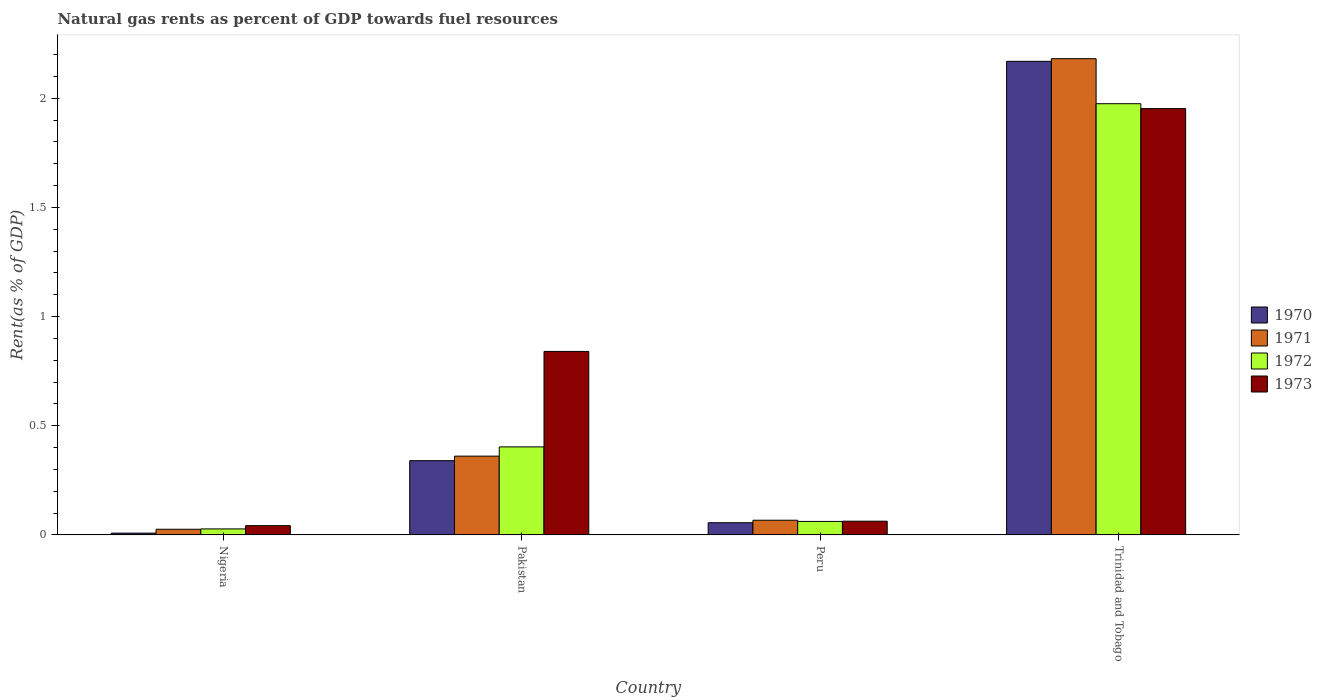Are the number of bars per tick equal to the number of legend labels?
Offer a very short reply. Yes. How many bars are there on the 4th tick from the left?
Provide a succinct answer. 4. How many bars are there on the 3rd tick from the right?
Give a very brief answer. 4. What is the matural gas rent in 1970 in Pakistan?
Keep it short and to the point. 0.34. Across all countries, what is the maximum matural gas rent in 1971?
Your response must be concise. 2.18. Across all countries, what is the minimum matural gas rent in 1972?
Your answer should be compact. 0.03. In which country was the matural gas rent in 1973 maximum?
Offer a very short reply. Trinidad and Tobago. In which country was the matural gas rent in 1970 minimum?
Provide a short and direct response. Nigeria. What is the total matural gas rent in 1971 in the graph?
Your answer should be compact. 2.64. What is the difference between the matural gas rent in 1972 in Nigeria and that in Trinidad and Tobago?
Provide a short and direct response. -1.95. What is the difference between the matural gas rent in 1970 in Peru and the matural gas rent in 1971 in Nigeria?
Your response must be concise. 0.03. What is the average matural gas rent in 1970 per country?
Offer a very short reply. 0.64. What is the difference between the matural gas rent of/in 1971 and matural gas rent of/in 1973 in Trinidad and Tobago?
Ensure brevity in your answer.  0.23. In how many countries, is the matural gas rent in 1971 greater than 1.6 %?
Ensure brevity in your answer.  1. What is the ratio of the matural gas rent in 1970 in Pakistan to that in Peru?
Provide a succinct answer. 6.1. Is the matural gas rent in 1970 in Nigeria less than that in Pakistan?
Your response must be concise. Yes. What is the difference between the highest and the second highest matural gas rent in 1970?
Provide a succinct answer. -1.83. What is the difference between the highest and the lowest matural gas rent in 1971?
Offer a terse response. 2.16. Is it the case that in every country, the sum of the matural gas rent in 1973 and matural gas rent in 1971 is greater than the sum of matural gas rent in 1970 and matural gas rent in 1972?
Make the answer very short. No. What does the 1st bar from the left in Pakistan represents?
Make the answer very short. 1970. What does the 4th bar from the right in Peru represents?
Provide a succinct answer. 1970. Are all the bars in the graph horizontal?
Ensure brevity in your answer.  No. Are the values on the major ticks of Y-axis written in scientific E-notation?
Offer a terse response. No. Does the graph contain any zero values?
Your answer should be compact. No. Does the graph contain grids?
Offer a very short reply. No. Where does the legend appear in the graph?
Give a very brief answer. Center right. How are the legend labels stacked?
Keep it short and to the point. Vertical. What is the title of the graph?
Make the answer very short. Natural gas rents as percent of GDP towards fuel resources. What is the label or title of the Y-axis?
Offer a terse response. Rent(as % of GDP). What is the Rent(as % of GDP) in 1970 in Nigeria?
Your answer should be compact. 0.01. What is the Rent(as % of GDP) in 1971 in Nigeria?
Make the answer very short. 0.03. What is the Rent(as % of GDP) in 1972 in Nigeria?
Keep it short and to the point. 0.03. What is the Rent(as % of GDP) in 1973 in Nigeria?
Your answer should be very brief. 0.04. What is the Rent(as % of GDP) in 1970 in Pakistan?
Ensure brevity in your answer.  0.34. What is the Rent(as % of GDP) in 1971 in Pakistan?
Your response must be concise. 0.36. What is the Rent(as % of GDP) in 1972 in Pakistan?
Offer a very short reply. 0.4. What is the Rent(as % of GDP) in 1973 in Pakistan?
Keep it short and to the point. 0.84. What is the Rent(as % of GDP) of 1970 in Peru?
Make the answer very short. 0.06. What is the Rent(as % of GDP) of 1971 in Peru?
Your response must be concise. 0.07. What is the Rent(as % of GDP) in 1972 in Peru?
Your answer should be compact. 0.06. What is the Rent(as % of GDP) in 1973 in Peru?
Provide a succinct answer. 0.06. What is the Rent(as % of GDP) of 1970 in Trinidad and Tobago?
Ensure brevity in your answer.  2.17. What is the Rent(as % of GDP) of 1971 in Trinidad and Tobago?
Offer a terse response. 2.18. What is the Rent(as % of GDP) of 1972 in Trinidad and Tobago?
Your answer should be compact. 1.98. What is the Rent(as % of GDP) in 1973 in Trinidad and Tobago?
Offer a terse response. 1.95. Across all countries, what is the maximum Rent(as % of GDP) of 1970?
Make the answer very short. 2.17. Across all countries, what is the maximum Rent(as % of GDP) in 1971?
Ensure brevity in your answer.  2.18. Across all countries, what is the maximum Rent(as % of GDP) in 1972?
Give a very brief answer. 1.98. Across all countries, what is the maximum Rent(as % of GDP) in 1973?
Your response must be concise. 1.95. Across all countries, what is the minimum Rent(as % of GDP) of 1970?
Your response must be concise. 0.01. Across all countries, what is the minimum Rent(as % of GDP) in 1971?
Give a very brief answer. 0.03. Across all countries, what is the minimum Rent(as % of GDP) of 1972?
Provide a short and direct response. 0.03. Across all countries, what is the minimum Rent(as % of GDP) of 1973?
Give a very brief answer. 0.04. What is the total Rent(as % of GDP) of 1970 in the graph?
Ensure brevity in your answer.  2.57. What is the total Rent(as % of GDP) of 1971 in the graph?
Offer a terse response. 2.64. What is the total Rent(as % of GDP) in 1972 in the graph?
Your response must be concise. 2.47. What is the total Rent(as % of GDP) of 1973 in the graph?
Your answer should be compact. 2.9. What is the difference between the Rent(as % of GDP) in 1970 in Nigeria and that in Pakistan?
Offer a terse response. -0.33. What is the difference between the Rent(as % of GDP) in 1971 in Nigeria and that in Pakistan?
Provide a succinct answer. -0.34. What is the difference between the Rent(as % of GDP) of 1972 in Nigeria and that in Pakistan?
Keep it short and to the point. -0.38. What is the difference between the Rent(as % of GDP) in 1973 in Nigeria and that in Pakistan?
Your answer should be very brief. -0.8. What is the difference between the Rent(as % of GDP) in 1970 in Nigeria and that in Peru?
Keep it short and to the point. -0.05. What is the difference between the Rent(as % of GDP) of 1971 in Nigeria and that in Peru?
Provide a short and direct response. -0.04. What is the difference between the Rent(as % of GDP) of 1972 in Nigeria and that in Peru?
Your answer should be very brief. -0.03. What is the difference between the Rent(as % of GDP) of 1973 in Nigeria and that in Peru?
Offer a terse response. -0.02. What is the difference between the Rent(as % of GDP) of 1970 in Nigeria and that in Trinidad and Tobago?
Ensure brevity in your answer.  -2.16. What is the difference between the Rent(as % of GDP) of 1971 in Nigeria and that in Trinidad and Tobago?
Give a very brief answer. -2.16. What is the difference between the Rent(as % of GDP) in 1972 in Nigeria and that in Trinidad and Tobago?
Ensure brevity in your answer.  -1.95. What is the difference between the Rent(as % of GDP) in 1973 in Nigeria and that in Trinidad and Tobago?
Make the answer very short. -1.91. What is the difference between the Rent(as % of GDP) of 1970 in Pakistan and that in Peru?
Offer a very short reply. 0.28. What is the difference between the Rent(as % of GDP) in 1971 in Pakistan and that in Peru?
Give a very brief answer. 0.29. What is the difference between the Rent(as % of GDP) in 1972 in Pakistan and that in Peru?
Your response must be concise. 0.34. What is the difference between the Rent(as % of GDP) of 1973 in Pakistan and that in Peru?
Keep it short and to the point. 0.78. What is the difference between the Rent(as % of GDP) in 1970 in Pakistan and that in Trinidad and Tobago?
Provide a succinct answer. -1.83. What is the difference between the Rent(as % of GDP) of 1971 in Pakistan and that in Trinidad and Tobago?
Provide a succinct answer. -1.82. What is the difference between the Rent(as % of GDP) in 1972 in Pakistan and that in Trinidad and Tobago?
Keep it short and to the point. -1.57. What is the difference between the Rent(as % of GDP) in 1973 in Pakistan and that in Trinidad and Tobago?
Keep it short and to the point. -1.11. What is the difference between the Rent(as % of GDP) in 1970 in Peru and that in Trinidad and Tobago?
Provide a short and direct response. -2.11. What is the difference between the Rent(as % of GDP) of 1971 in Peru and that in Trinidad and Tobago?
Provide a short and direct response. -2.11. What is the difference between the Rent(as % of GDP) in 1972 in Peru and that in Trinidad and Tobago?
Your answer should be very brief. -1.91. What is the difference between the Rent(as % of GDP) in 1973 in Peru and that in Trinidad and Tobago?
Provide a succinct answer. -1.89. What is the difference between the Rent(as % of GDP) of 1970 in Nigeria and the Rent(as % of GDP) of 1971 in Pakistan?
Keep it short and to the point. -0.35. What is the difference between the Rent(as % of GDP) in 1970 in Nigeria and the Rent(as % of GDP) in 1972 in Pakistan?
Keep it short and to the point. -0.4. What is the difference between the Rent(as % of GDP) of 1970 in Nigeria and the Rent(as % of GDP) of 1973 in Pakistan?
Provide a succinct answer. -0.83. What is the difference between the Rent(as % of GDP) of 1971 in Nigeria and the Rent(as % of GDP) of 1972 in Pakistan?
Offer a terse response. -0.38. What is the difference between the Rent(as % of GDP) of 1971 in Nigeria and the Rent(as % of GDP) of 1973 in Pakistan?
Your response must be concise. -0.81. What is the difference between the Rent(as % of GDP) in 1972 in Nigeria and the Rent(as % of GDP) in 1973 in Pakistan?
Provide a succinct answer. -0.81. What is the difference between the Rent(as % of GDP) in 1970 in Nigeria and the Rent(as % of GDP) in 1971 in Peru?
Provide a short and direct response. -0.06. What is the difference between the Rent(as % of GDP) of 1970 in Nigeria and the Rent(as % of GDP) of 1972 in Peru?
Your response must be concise. -0.05. What is the difference between the Rent(as % of GDP) in 1970 in Nigeria and the Rent(as % of GDP) in 1973 in Peru?
Provide a short and direct response. -0.05. What is the difference between the Rent(as % of GDP) of 1971 in Nigeria and the Rent(as % of GDP) of 1972 in Peru?
Ensure brevity in your answer.  -0.04. What is the difference between the Rent(as % of GDP) of 1971 in Nigeria and the Rent(as % of GDP) of 1973 in Peru?
Give a very brief answer. -0.04. What is the difference between the Rent(as % of GDP) in 1972 in Nigeria and the Rent(as % of GDP) in 1973 in Peru?
Your answer should be very brief. -0.04. What is the difference between the Rent(as % of GDP) of 1970 in Nigeria and the Rent(as % of GDP) of 1971 in Trinidad and Tobago?
Make the answer very short. -2.17. What is the difference between the Rent(as % of GDP) of 1970 in Nigeria and the Rent(as % of GDP) of 1972 in Trinidad and Tobago?
Your response must be concise. -1.97. What is the difference between the Rent(as % of GDP) of 1970 in Nigeria and the Rent(as % of GDP) of 1973 in Trinidad and Tobago?
Ensure brevity in your answer.  -1.94. What is the difference between the Rent(as % of GDP) in 1971 in Nigeria and the Rent(as % of GDP) in 1972 in Trinidad and Tobago?
Your response must be concise. -1.95. What is the difference between the Rent(as % of GDP) in 1971 in Nigeria and the Rent(as % of GDP) in 1973 in Trinidad and Tobago?
Your answer should be compact. -1.93. What is the difference between the Rent(as % of GDP) in 1972 in Nigeria and the Rent(as % of GDP) in 1973 in Trinidad and Tobago?
Make the answer very short. -1.93. What is the difference between the Rent(as % of GDP) of 1970 in Pakistan and the Rent(as % of GDP) of 1971 in Peru?
Provide a succinct answer. 0.27. What is the difference between the Rent(as % of GDP) in 1970 in Pakistan and the Rent(as % of GDP) in 1972 in Peru?
Your answer should be very brief. 0.28. What is the difference between the Rent(as % of GDP) in 1970 in Pakistan and the Rent(as % of GDP) in 1973 in Peru?
Your answer should be compact. 0.28. What is the difference between the Rent(as % of GDP) of 1971 in Pakistan and the Rent(as % of GDP) of 1972 in Peru?
Make the answer very short. 0.3. What is the difference between the Rent(as % of GDP) of 1971 in Pakistan and the Rent(as % of GDP) of 1973 in Peru?
Give a very brief answer. 0.3. What is the difference between the Rent(as % of GDP) of 1972 in Pakistan and the Rent(as % of GDP) of 1973 in Peru?
Make the answer very short. 0.34. What is the difference between the Rent(as % of GDP) of 1970 in Pakistan and the Rent(as % of GDP) of 1971 in Trinidad and Tobago?
Ensure brevity in your answer.  -1.84. What is the difference between the Rent(as % of GDP) in 1970 in Pakistan and the Rent(as % of GDP) in 1972 in Trinidad and Tobago?
Provide a succinct answer. -1.64. What is the difference between the Rent(as % of GDP) in 1970 in Pakistan and the Rent(as % of GDP) in 1973 in Trinidad and Tobago?
Your response must be concise. -1.61. What is the difference between the Rent(as % of GDP) of 1971 in Pakistan and the Rent(as % of GDP) of 1972 in Trinidad and Tobago?
Your answer should be compact. -1.61. What is the difference between the Rent(as % of GDP) in 1971 in Pakistan and the Rent(as % of GDP) in 1973 in Trinidad and Tobago?
Give a very brief answer. -1.59. What is the difference between the Rent(as % of GDP) of 1972 in Pakistan and the Rent(as % of GDP) of 1973 in Trinidad and Tobago?
Make the answer very short. -1.55. What is the difference between the Rent(as % of GDP) in 1970 in Peru and the Rent(as % of GDP) in 1971 in Trinidad and Tobago?
Your answer should be compact. -2.13. What is the difference between the Rent(as % of GDP) of 1970 in Peru and the Rent(as % of GDP) of 1972 in Trinidad and Tobago?
Provide a succinct answer. -1.92. What is the difference between the Rent(as % of GDP) of 1970 in Peru and the Rent(as % of GDP) of 1973 in Trinidad and Tobago?
Your answer should be very brief. -1.9. What is the difference between the Rent(as % of GDP) in 1971 in Peru and the Rent(as % of GDP) in 1972 in Trinidad and Tobago?
Your response must be concise. -1.91. What is the difference between the Rent(as % of GDP) of 1971 in Peru and the Rent(as % of GDP) of 1973 in Trinidad and Tobago?
Ensure brevity in your answer.  -1.89. What is the difference between the Rent(as % of GDP) of 1972 in Peru and the Rent(as % of GDP) of 1973 in Trinidad and Tobago?
Offer a very short reply. -1.89. What is the average Rent(as % of GDP) in 1970 per country?
Your answer should be very brief. 0.64. What is the average Rent(as % of GDP) of 1971 per country?
Your answer should be very brief. 0.66. What is the average Rent(as % of GDP) in 1972 per country?
Make the answer very short. 0.62. What is the average Rent(as % of GDP) of 1973 per country?
Your answer should be very brief. 0.72. What is the difference between the Rent(as % of GDP) of 1970 and Rent(as % of GDP) of 1971 in Nigeria?
Ensure brevity in your answer.  -0.02. What is the difference between the Rent(as % of GDP) of 1970 and Rent(as % of GDP) of 1972 in Nigeria?
Give a very brief answer. -0.02. What is the difference between the Rent(as % of GDP) of 1970 and Rent(as % of GDP) of 1973 in Nigeria?
Give a very brief answer. -0.03. What is the difference between the Rent(as % of GDP) in 1971 and Rent(as % of GDP) in 1972 in Nigeria?
Offer a terse response. -0. What is the difference between the Rent(as % of GDP) in 1971 and Rent(as % of GDP) in 1973 in Nigeria?
Keep it short and to the point. -0.02. What is the difference between the Rent(as % of GDP) of 1972 and Rent(as % of GDP) of 1973 in Nigeria?
Your answer should be very brief. -0.01. What is the difference between the Rent(as % of GDP) of 1970 and Rent(as % of GDP) of 1971 in Pakistan?
Offer a very short reply. -0.02. What is the difference between the Rent(as % of GDP) of 1970 and Rent(as % of GDP) of 1972 in Pakistan?
Your response must be concise. -0.06. What is the difference between the Rent(as % of GDP) in 1970 and Rent(as % of GDP) in 1973 in Pakistan?
Offer a terse response. -0.5. What is the difference between the Rent(as % of GDP) of 1971 and Rent(as % of GDP) of 1972 in Pakistan?
Provide a short and direct response. -0.04. What is the difference between the Rent(as % of GDP) of 1971 and Rent(as % of GDP) of 1973 in Pakistan?
Your answer should be compact. -0.48. What is the difference between the Rent(as % of GDP) in 1972 and Rent(as % of GDP) in 1973 in Pakistan?
Ensure brevity in your answer.  -0.44. What is the difference between the Rent(as % of GDP) in 1970 and Rent(as % of GDP) in 1971 in Peru?
Provide a succinct answer. -0.01. What is the difference between the Rent(as % of GDP) in 1970 and Rent(as % of GDP) in 1972 in Peru?
Ensure brevity in your answer.  -0.01. What is the difference between the Rent(as % of GDP) of 1970 and Rent(as % of GDP) of 1973 in Peru?
Offer a very short reply. -0.01. What is the difference between the Rent(as % of GDP) in 1971 and Rent(as % of GDP) in 1972 in Peru?
Make the answer very short. 0.01. What is the difference between the Rent(as % of GDP) of 1971 and Rent(as % of GDP) of 1973 in Peru?
Offer a very short reply. 0. What is the difference between the Rent(as % of GDP) of 1972 and Rent(as % of GDP) of 1973 in Peru?
Provide a short and direct response. -0. What is the difference between the Rent(as % of GDP) of 1970 and Rent(as % of GDP) of 1971 in Trinidad and Tobago?
Your response must be concise. -0.01. What is the difference between the Rent(as % of GDP) of 1970 and Rent(as % of GDP) of 1972 in Trinidad and Tobago?
Offer a very short reply. 0.19. What is the difference between the Rent(as % of GDP) in 1970 and Rent(as % of GDP) in 1973 in Trinidad and Tobago?
Your answer should be very brief. 0.22. What is the difference between the Rent(as % of GDP) of 1971 and Rent(as % of GDP) of 1972 in Trinidad and Tobago?
Provide a short and direct response. 0.21. What is the difference between the Rent(as % of GDP) of 1971 and Rent(as % of GDP) of 1973 in Trinidad and Tobago?
Keep it short and to the point. 0.23. What is the difference between the Rent(as % of GDP) of 1972 and Rent(as % of GDP) of 1973 in Trinidad and Tobago?
Give a very brief answer. 0.02. What is the ratio of the Rent(as % of GDP) of 1970 in Nigeria to that in Pakistan?
Keep it short and to the point. 0.02. What is the ratio of the Rent(as % of GDP) in 1971 in Nigeria to that in Pakistan?
Offer a terse response. 0.07. What is the ratio of the Rent(as % of GDP) of 1972 in Nigeria to that in Pakistan?
Your answer should be compact. 0.07. What is the ratio of the Rent(as % of GDP) in 1973 in Nigeria to that in Pakistan?
Offer a very short reply. 0.05. What is the ratio of the Rent(as % of GDP) of 1970 in Nigeria to that in Peru?
Ensure brevity in your answer.  0.15. What is the ratio of the Rent(as % of GDP) of 1971 in Nigeria to that in Peru?
Your answer should be very brief. 0.38. What is the ratio of the Rent(as % of GDP) of 1972 in Nigeria to that in Peru?
Your response must be concise. 0.44. What is the ratio of the Rent(as % of GDP) of 1973 in Nigeria to that in Peru?
Offer a terse response. 0.67. What is the ratio of the Rent(as % of GDP) of 1970 in Nigeria to that in Trinidad and Tobago?
Your answer should be very brief. 0. What is the ratio of the Rent(as % of GDP) of 1971 in Nigeria to that in Trinidad and Tobago?
Ensure brevity in your answer.  0.01. What is the ratio of the Rent(as % of GDP) of 1972 in Nigeria to that in Trinidad and Tobago?
Keep it short and to the point. 0.01. What is the ratio of the Rent(as % of GDP) in 1973 in Nigeria to that in Trinidad and Tobago?
Make the answer very short. 0.02. What is the ratio of the Rent(as % of GDP) in 1970 in Pakistan to that in Peru?
Your response must be concise. 6.1. What is the ratio of the Rent(as % of GDP) of 1971 in Pakistan to that in Peru?
Offer a very short reply. 5.37. What is the ratio of the Rent(as % of GDP) in 1972 in Pakistan to that in Peru?
Your answer should be compact. 6.54. What is the ratio of the Rent(as % of GDP) of 1973 in Pakistan to that in Peru?
Offer a very short reply. 13.39. What is the ratio of the Rent(as % of GDP) of 1970 in Pakistan to that in Trinidad and Tobago?
Offer a terse response. 0.16. What is the ratio of the Rent(as % of GDP) in 1971 in Pakistan to that in Trinidad and Tobago?
Give a very brief answer. 0.17. What is the ratio of the Rent(as % of GDP) in 1972 in Pakistan to that in Trinidad and Tobago?
Offer a very short reply. 0.2. What is the ratio of the Rent(as % of GDP) of 1973 in Pakistan to that in Trinidad and Tobago?
Your answer should be very brief. 0.43. What is the ratio of the Rent(as % of GDP) in 1970 in Peru to that in Trinidad and Tobago?
Offer a terse response. 0.03. What is the ratio of the Rent(as % of GDP) in 1971 in Peru to that in Trinidad and Tobago?
Your answer should be very brief. 0.03. What is the ratio of the Rent(as % of GDP) in 1972 in Peru to that in Trinidad and Tobago?
Keep it short and to the point. 0.03. What is the ratio of the Rent(as % of GDP) of 1973 in Peru to that in Trinidad and Tobago?
Your answer should be very brief. 0.03. What is the difference between the highest and the second highest Rent(as % of GDP) in 1970?
Provide a succinct answer. 1.83. What is the difference between the highest and the second highest Rent(as % of GDP) of 1971?
Your answer should be very brief. 1.82. What is the difference between the highest and the second highest Rent(as % of GDP) in 1972?
Offer a very short reply. 1.57. What is the difference between the highest and the second highest Rent(as % of GDP) of 1973?
Your answer should be compact. 1.11. What is the difference between the highest and the lowest Rent(as % of GDP) of 1970?
Provide a short and direct response. 2.16. What is the difference between the highest and the lowest Rent(as % of GDP) in 1971?
Ensure brevity in your answer.  2.16. What is the difference between the highest and the lowest Rent(as % of GDP) of 1972?
Your answer should be compact. 1.95. What is the difference between the highest and the lowest Rent(as % of GDP) in 1973?
Keep it short and to the point. 1.91. 